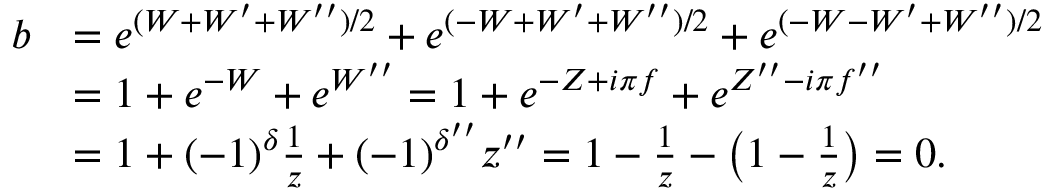<formula> <loc_0><loc_0><loc_500><loc_500>\begin{array} { r l } { b } & { = e ^ { ( W + W ^ { \prime } + W ^ { \prime \prime } ) / 2 } + e ^ { ( - W + W ^ { \prime } + W ^ { \prime \prime } ) / 2 } + e ^ { ( - W - W ^ { \prime } + W ^ { \prime \prime } ) / 2 } } \\ & { = 1 + e ^ { - W } + e ^ { W ^ { \prime \prime } } = 1 + e ^ { - Z + i \pi f } + e ^ { Z ^ { \prime \prime } - i \pi f ^ { \prime \prime } } } \\ & { = 1 + ( - 1 ) ^ { \delta } \frac { 1 } { z } + ( - 1 ) ^ { \delta ^ { \prime \prime } } z ^ { \prime \prime } = 1 - \frac { 1 } { z } - \left ( 1 - \frac { 1 } { z } \right ) = 0 . } \end{array}</formula> 